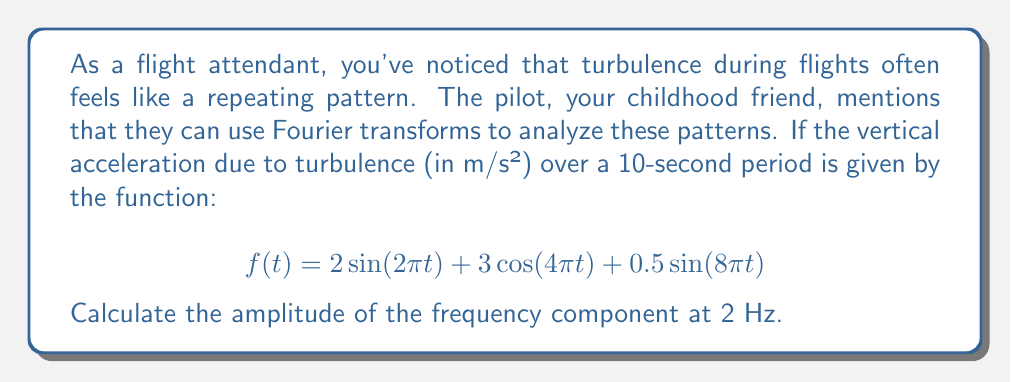Could you help me with this problem? To solve this problem, we'll follow these steps:

1) First, recall that the Fourier transform of a continuous-time signal $f(t)$ is given by:

   $$F(\omega) = \int_{-\infty}^{\infty} f(t) e^{-i\omega t} dt$$

2) In our case, we're interested in the frequency components, so we'll use the frequency form of the Fourier transform:

   $$F(f) = \int_{-\infty}^{\infty} f(t) e^{-i2\pi ft} dt$$

3) Our function $f(t)$ is composed of three terms:
   
   $$f(t) = 2\sin(2\pi t) + 3\cos(4\pi t) + 0.5\sin(8\pi t)$$

4) We're asked about the 2 Hz component. Looking at our function:
   - $2\sin(2\pi t)$ has a frequency of 1 Hz
   - $3\cos(4\pi t)$ has a frequency of 2 Hz
   - $0.5\sin(8\pi t)$ has a frequency of 4 Hz

5) The 2 Hz component comes from the term $3\cos(4\pi t)$. 

6) For a cosine function $A\cos(2\pi ft)$, the amplitude in the frequency domain is $A/2$ at frequency $f$ and $-f$.

7) In our case, $A = 3$ and $f = 2$ Hz.

Therefore, the amplitude of the 2 Hz component in the frequency domain is $3/2 = 1.5$.
Answer: The amplitude of the frequency component at 2 Hz is 1.5 m/s². 